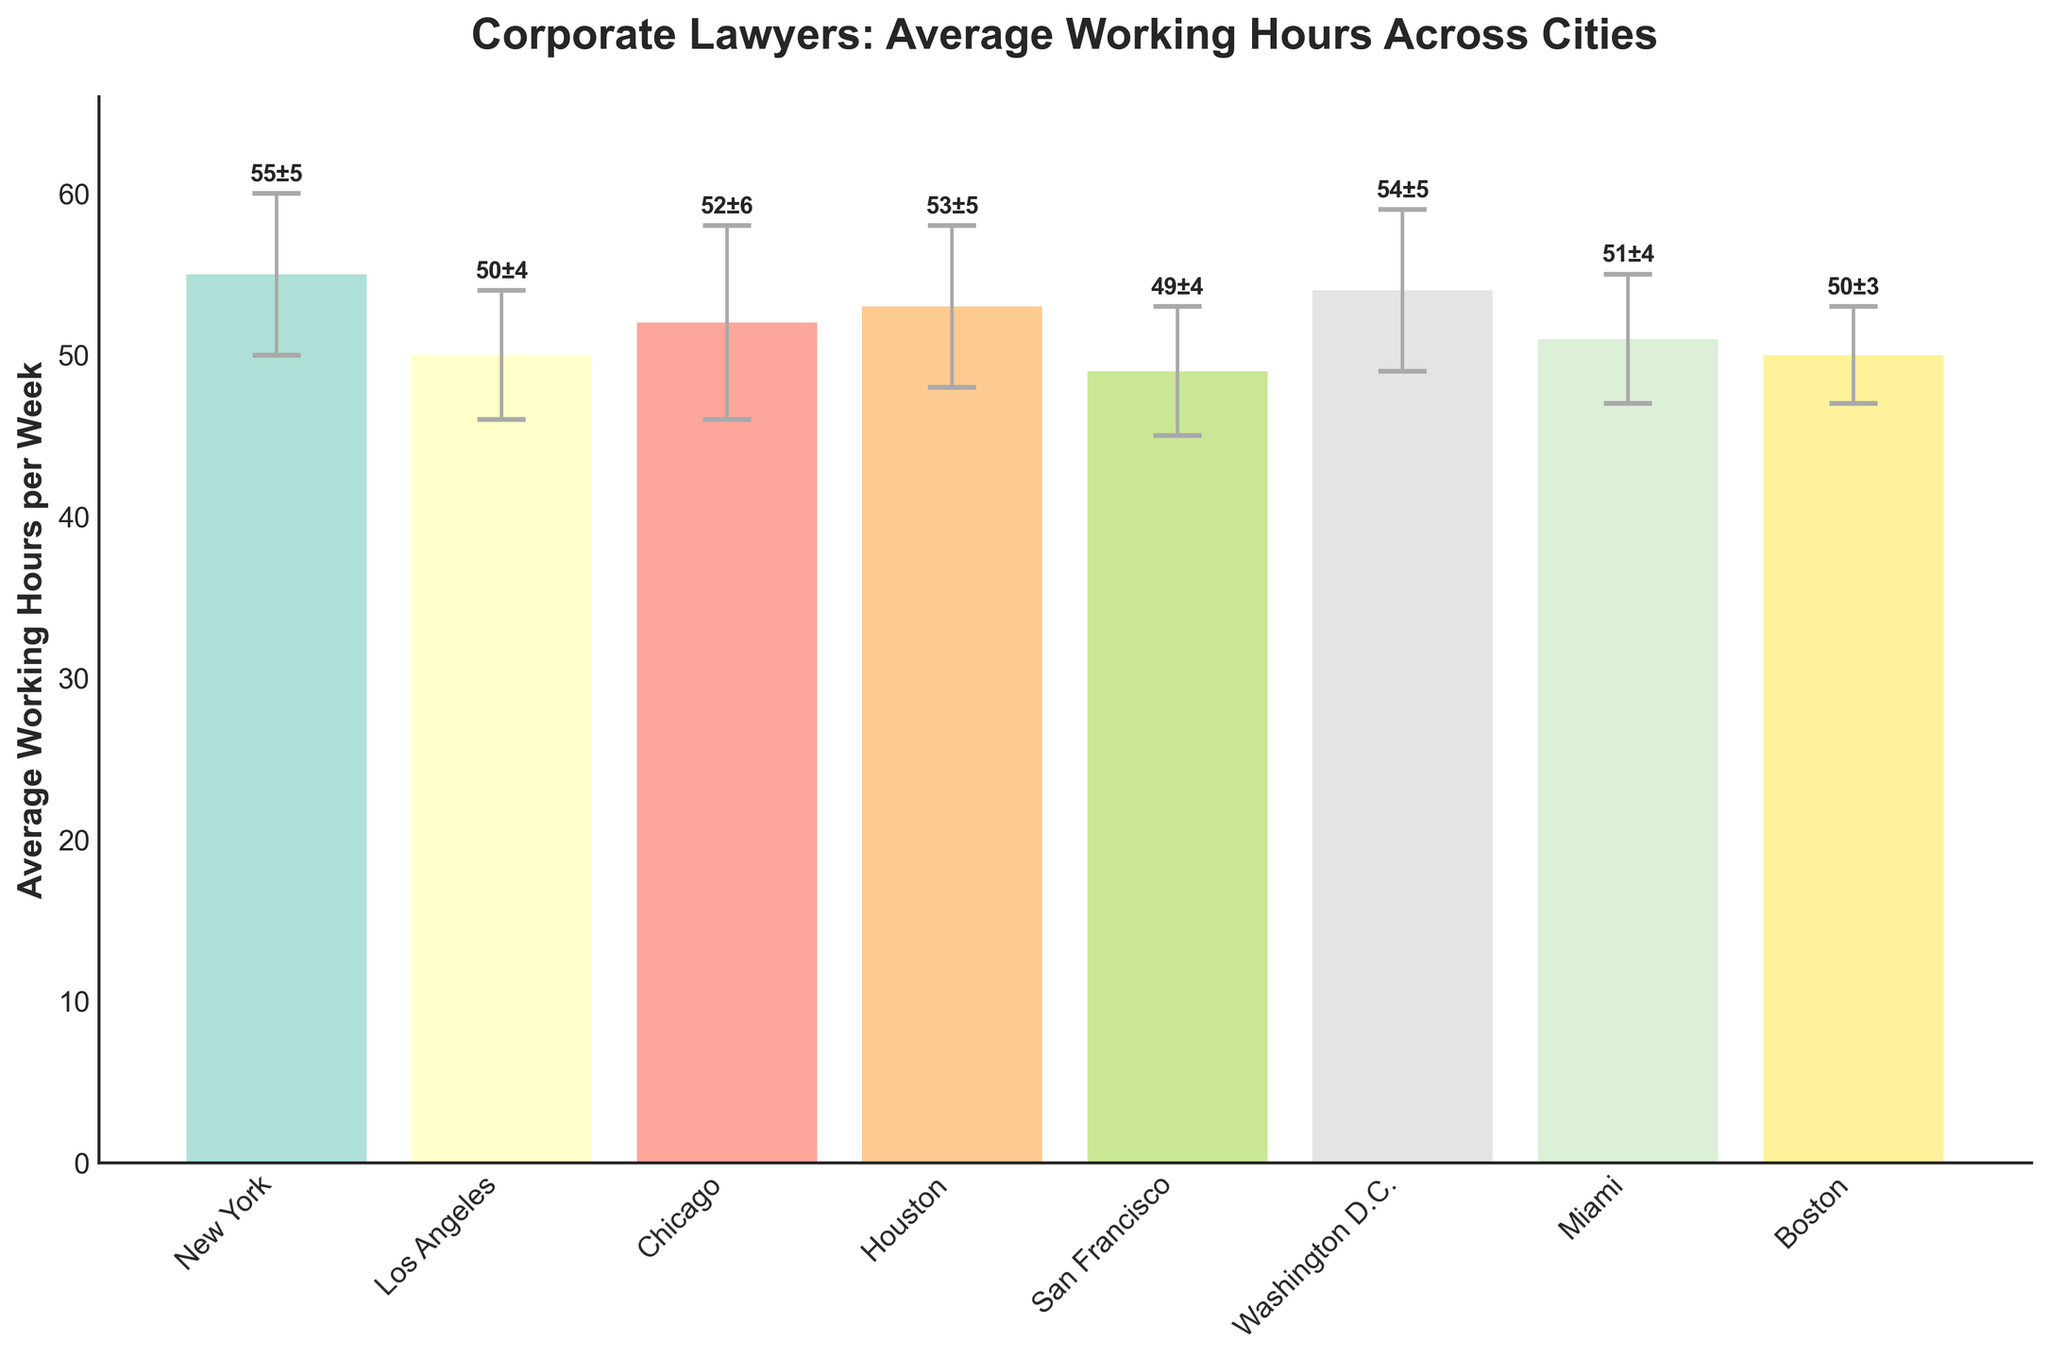What's the title of the plot? The title is located at the top of the plot and is formatted in a larger, bolded font.
Answer: Corporate Lawyers: Average Working Hours Across Cities How many cities are shown in the plot? Count the number of bars in the plot, each representing a different city.
Answer: 8 Which city has the highest average working hours per week? Identify the tallest bar in the plot, which represents the city with the highest average working hours.
Answer: New York Which city has the lowest average working hours per week? Identify the shortest bar in the plot, which represents the city with the lowest average working hours.
Answer: San Francisco What is the average working hours for Washington D.C.? Look at the height of the bar corresponding to Washington D.C. and read the value.
Answer: 54 What is the range of the average working hours per week across all cities? Find the difference between the highest and lowest average working hours values. The highest is 55 (New York) and the lowest is 49 (San Francisco).
Answer: 6 Which cities have a standard deviation of 4 hours? Look at the error bars and corresponding labels to identify which cities have a standard deviation of 4 hours.
Answer: Los Angeles, San Francisco, Miami What is the combined average working hours of Houston and Chicago? Add the average working hours for Houston (53) and Chicago (52).
Answer: 105 Is the average working hours for Miami greater than that of Los Angeles? Compare the heights of the bars for Miami (51) and Los Angeles (50).
Answer: Yes Which city has the highest standard deviation in average working hours? Identify the city with the longest error bar.
Answer: Chicago 